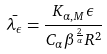Convert formula to latex. <formula><loc_0><loc_0><loc_500><loc_500>\bar { \lambda _ { \epsilon } } = \frac { K _ { \alpha , M } \epsilon } { C _ { \alpha } \beta ^ { \frac { 2 } { \alpha } } R ^ { 2 } }</formula> 